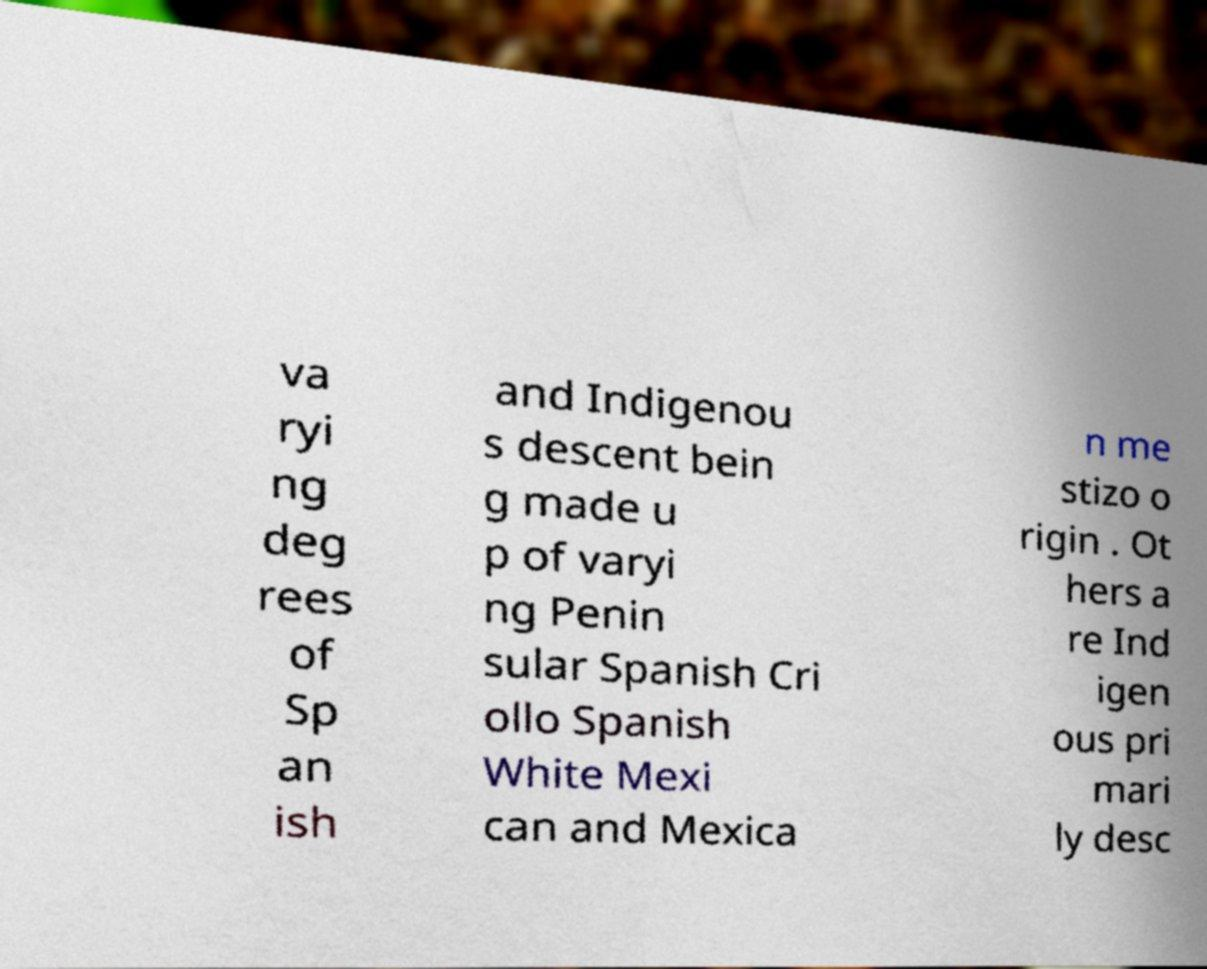I need the written content from this picture converted into text. Can you do that? va ryi ng deg rees of Sp an ish and Indigenou s descent bein g made u p of varyi ng Penin sular Spanish Cri ollo Spanish White Mexi can and Mexica n me stizo o rigin . Ot hers a re Ind igen ous pri mari ly desc 